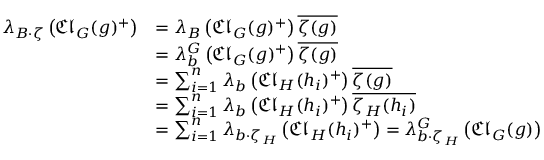Convert formula to latex. <formula><loc_0><loc_0><loc_500><loc_500>\begin{array} { r l } { \lambda _ { B \cdot \zeta } \left ( { \mathfrak { C l } } _ { G } ( g ) ^ { + } \right ) } & { = \lambda _ { B } \left ( { \mathfrak { C l } } _ { G } ( g ) ^ { + } \right ) \overline { \zeta ( g ) } } \\ & { = \lambda _ { b } ^ { G } \left ( { \mathfrak { C l } } _ { G } ( g ) ^ { + } \right ) \overline { \zeta ( g ) } } \\ & { = \sum _ { i = 1 } ^ { n } \lambda _ { b } \left ( { \mathfrak { C l } } _ { H } ( h _ { i } ) ^ { + } \right ) \overline { \zeta ( g ) } } \\ & { = \sum _ { i = 1 } ^ { n } \lambda _ { b } \left ( { \mathfrak { C l } } _ { H } ( h _ { i } ) ^ { + } \right ) \overline { { \zeta _ { H } ( h _ { i } ) } } } \\ & { = \sum _ { i = 1 } ^ { n } \lambda _ { b \cdot \zeta _ { H } } \left ( { \mathfrak { C l } } _ { H } ( h _ { i } ) ^ { + } \right ) = \lambda _ { b \cdot \zeta _ { H } } ^ { G } \left ( { \mathfrak { C l } } _ { G } ( g ) \right ) } \end{array}</formula> 